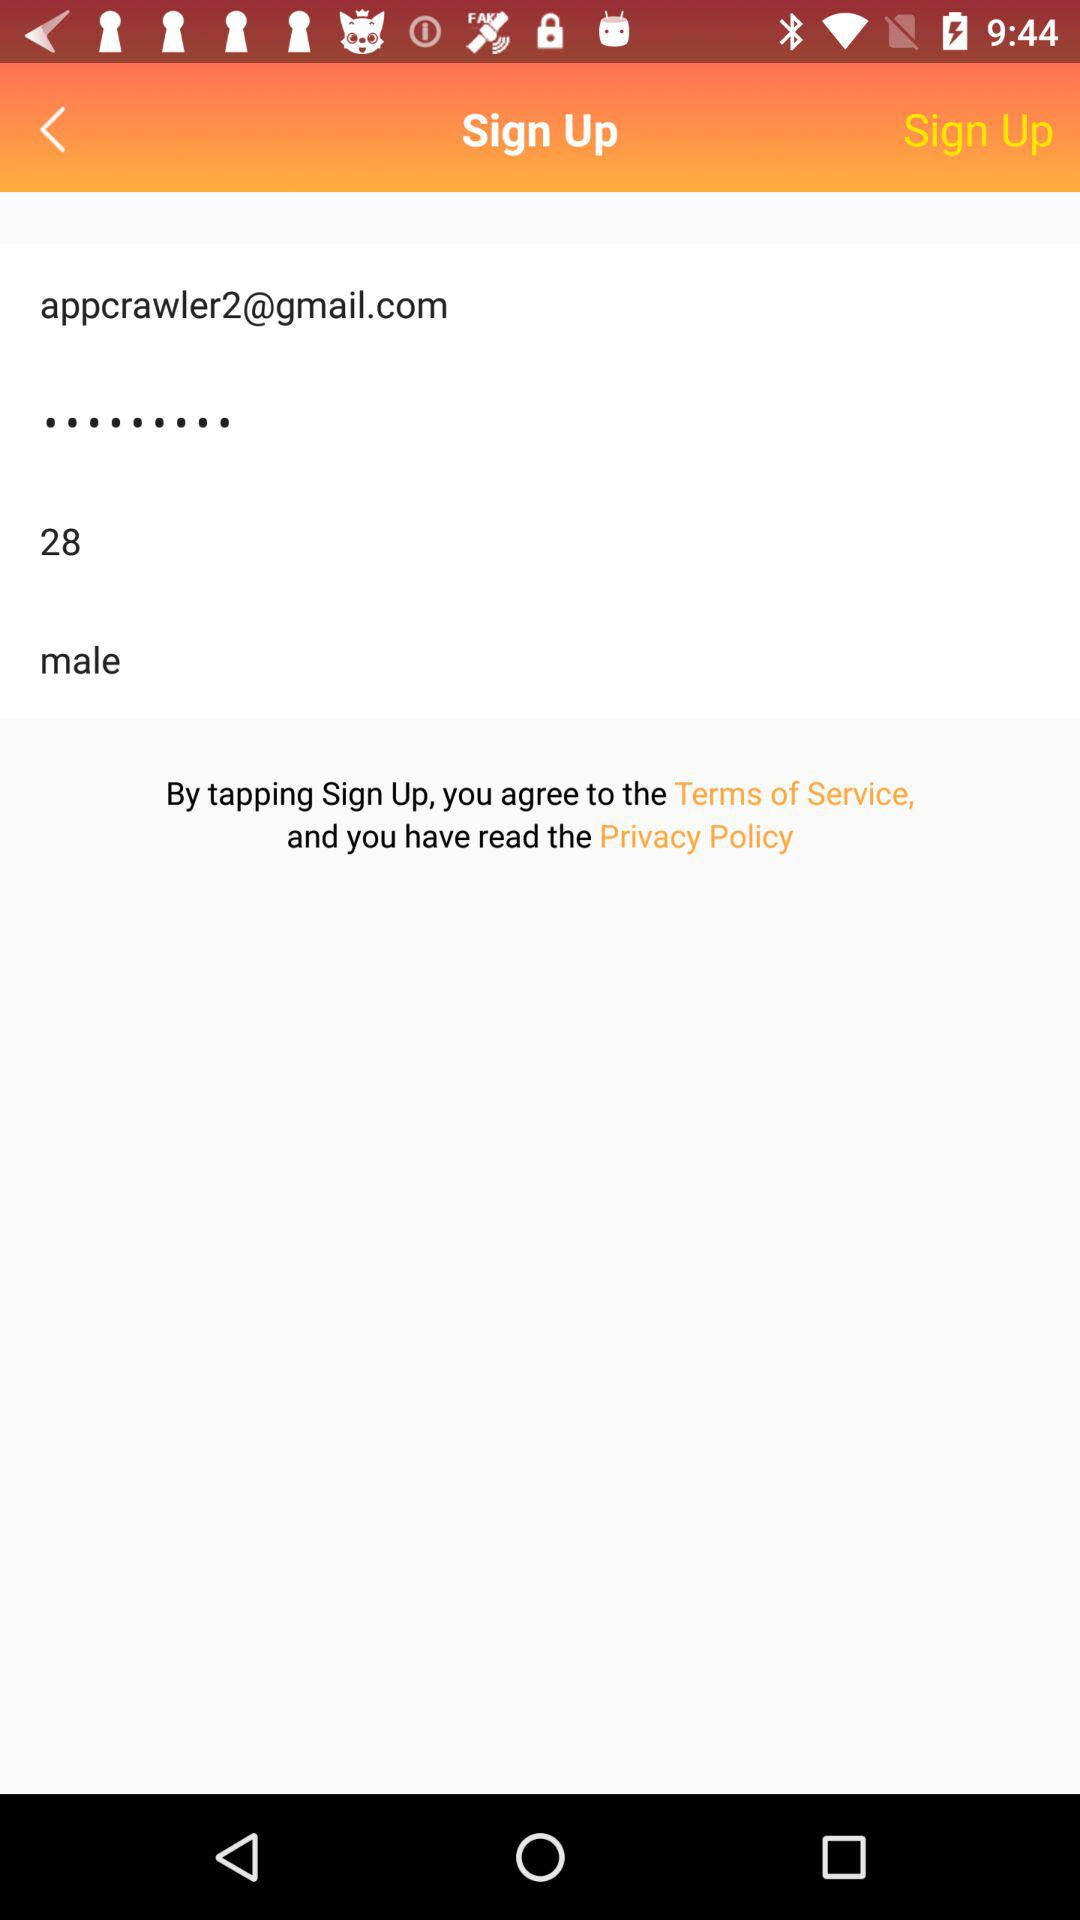What is the age? The age is 28. 